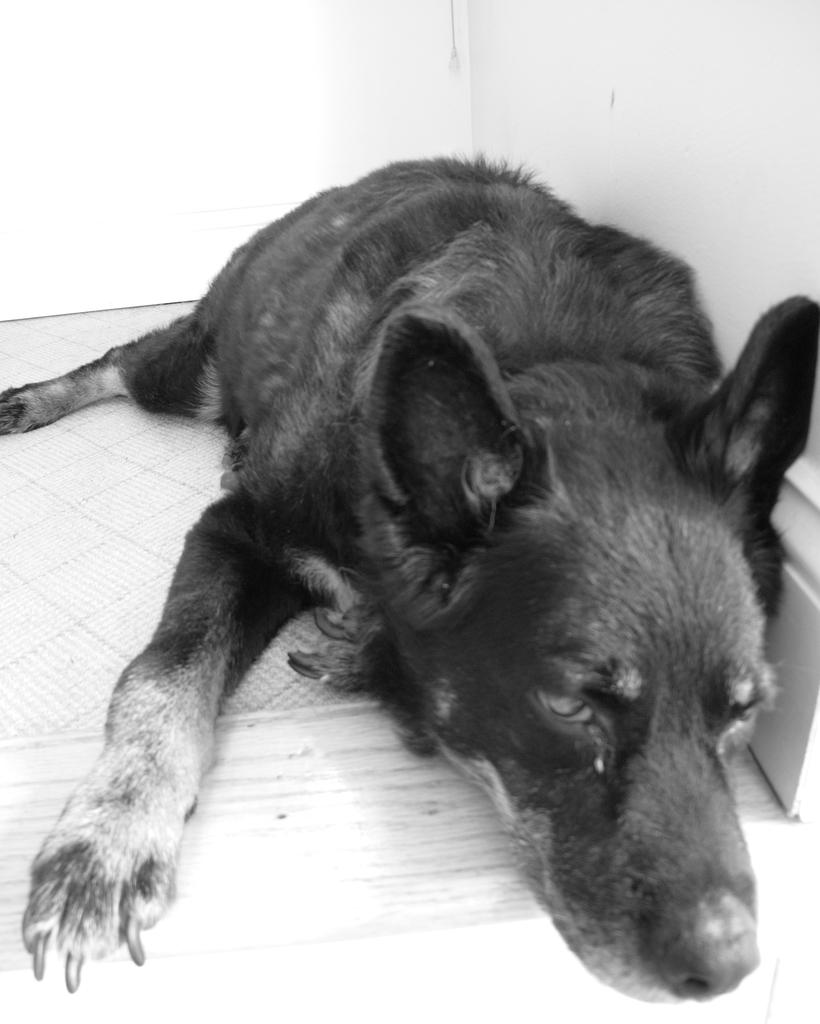What type of animal is in the image? There is a black dog in the image. What is the dog doing in the image? The dog is resting on the ground. What can be seen in the background of the image? There is a wall in the background of the image. What type of tooth is visible in the image? There is no tooth visible in the image; it features a black dog resting on the ground with a wall in the background. 